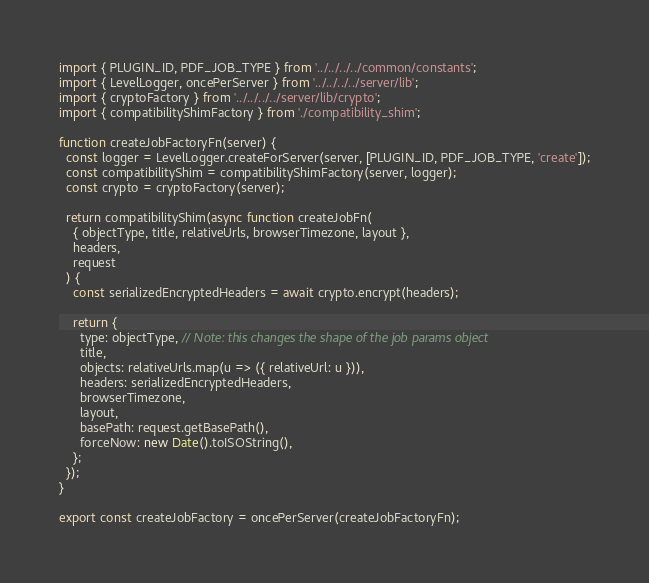Convert code to text. <code><loc_0><loc_0><loc_500><loc_500><_JavaScript_>
import { PLUGIN_ID, PDF_JOB_TYPE } from '../../../../common/constants';
import { LevelLogger, oncePerServer } from '../../../../server/lib';
import { cryptoFactory } from '../../../../server/lib/crypto';
import { compatibilityShimFactory } from './compatibility_shim';

function createJobFactoryFn(server) {
  const logger = LevelLogger.createForServer(server, [PLUGIN_ID, PDF_JOB_TYPE, 'create']);
  const compatibilityShim = compatibilityShimFactory(server, logger);
  const crypto = cryptoFactory(server);

  return compatibilityShim(async function createJobFn(
    { objectType, title, relativeUrls, browserTimezone, layout },
    headers,
    request
  ) {
    const serializedEncryptedHeaders = await crypto.encrypt(headers);

    return {
      type: objectType, // Note: this changes the shape of the job params object
      title,
      objects: relativeUrls.map(u => ({ relativeUrl: u })),
      headers: serializedEncryptedHeaders,
      browserTimezone,
      layout,
      basePath: request.getBasePath(),
      forceNow: new Date().toISOString(),
    };
  });
}

export const createJobFactory = oncePerServer(createJobFactoryFn);
</code> 